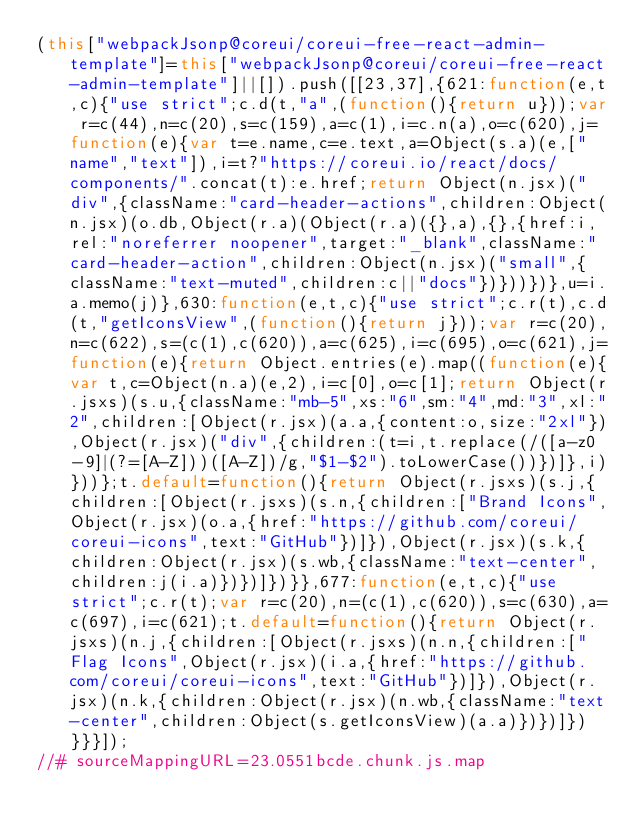Convert code to text. <code><loc_0><loc_0><loc_500><loc_500><_JavaScript_>(this["webpackJsonp@coreui/coreui-free-react-admin-template"]=this["webpackJsonp@coreui/coreui-free-react-admin-template"]||[]).push([[23,37],{621:function(e,t,c){"use strict";c.d(t,"a",(function(){return u}));var r=c(44),n=c(20),s=c(159),a=c(1),i=c.n(a),o=c(620),j=function(e){var t=e.name,c=e.text,a=Object(s.a)(e,["name","text"]),i=t?"https://coreui.io/react/docs/components/".concat(t):e.href;return Object(n.jsx)("div",{className:"card-header-actions",children:Object(n.jsx)(o.db,Object(r.a)(Object(r.a)({},a),{},{href:i,rel:"noreferrer noopener",target:"_blank",className:"card-header-action",children:Object(n.jsx)("small",{className:"text-muted",children:c||"docs"})}))})},u=i.a.memo(j)},630:function(e,t,c){"use strict";c.r(t),c.d(t,"getIconsView",(function(){return j}));var r=c(20),n=c(622),s=(c(1),c(620)),a=c(625),i=c(695),o=c(621),j=function(e){return Object.entries(e).map((function(e){var t,c=Object(n.a)(e,2),i=c[0],o=c[1];return Object(r.jsxs)(s.u,{className:"mb-5",xs:"6",sm:"4",md:"3",xl:"2",children:[Object(r.jsx)(a.a,{content:o,size:"2xl"}),Object(r.jsx)("div",{children:(t=i,t.replace(/([a-z0-9]|(?=[A-Z]))([A-Z])/g,"$1-$2").toLowerCase())})]},i)}))};t.default=function(){return Object(r.jsxs)(s.j,{children:[Object(r.jsxs)(s.n,{children:["Brand Icons",Object(r.jsx)(o.a,{href:"https://github.com/coreui/coreui-icons",text:"GitHub"})]}),Object(r.jsx)(s.k,{children:Object(r.jsx)(s.wb,{className:"text-center",children:j(i.a)})})]})}},677:function(e,t,c){"use strict";c.r(t);var r=c(20),n=(c(1),c(620)),s=c(630),a=c(697),i=c(621);t.default=function(){return Object(r.jsxs)(n.j,{children:[Object(r.jsxs)(n.n,{children:["Flag Icons",Object(r.jsx)(i.a,{href:"https://github.com/coreui/coreui-icons",text:"GitHub"})]}),Object(r.jsx)(n.k,{children:Object(r.jsx)(n.wb,{className:"text-center",children:Object(s.getIconsView)(a.a)})})]})}}}]);
//# sourceMappingURL=23.0551bcde.chunk.js.map</code> 